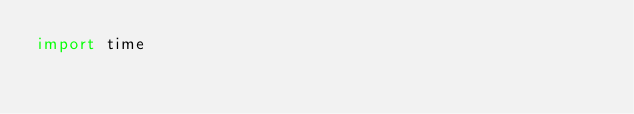Convert code to text. <code><loc_0><loc_0><loc_500><loc_500><_Python_>import time</code> 